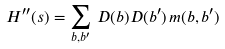<formula> <loc_0><loc_0><loc_500><loc_500>H ^ { \prime \prime } ( s ) = \sum _ { b , b ^ { \prime } } \, D ( b ) D ( b ^ { \prime } ) \, m ( b , b ^ { \prime } )</formula> 